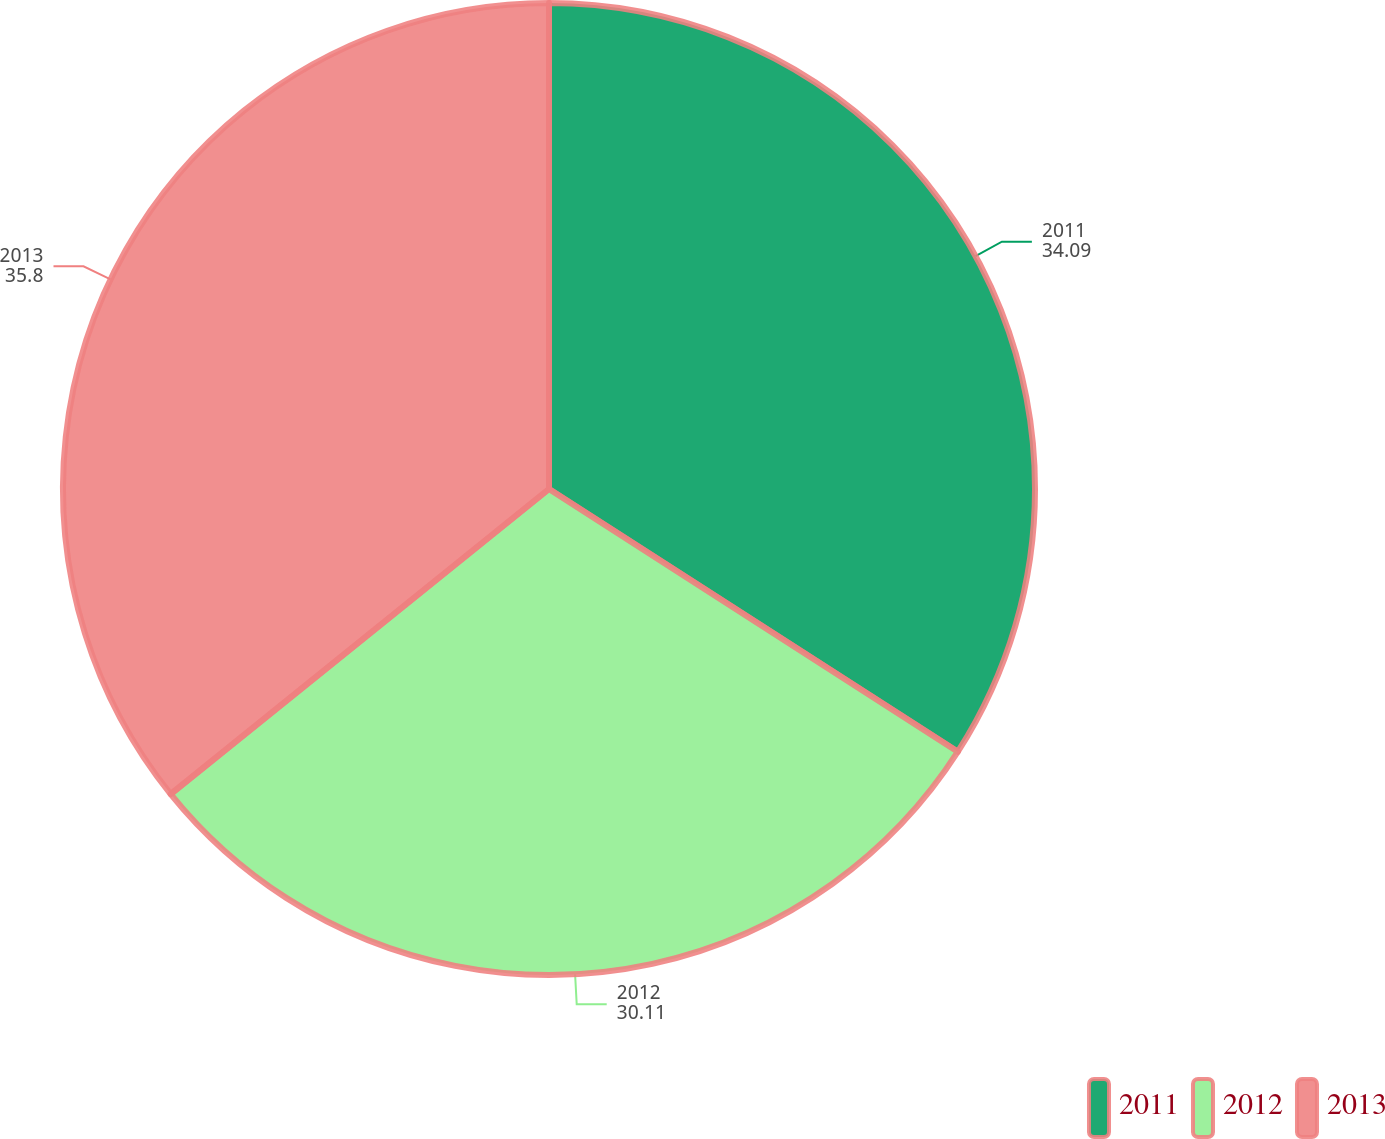<chart> <loc_0><loc_0><loc_500><loc_500><pie_chart><fcel>2011<fcel>2012<fcel>2013<nl><fcel>34.09%<fcel>30.11%<fcel>35.8%<nl></chart> 